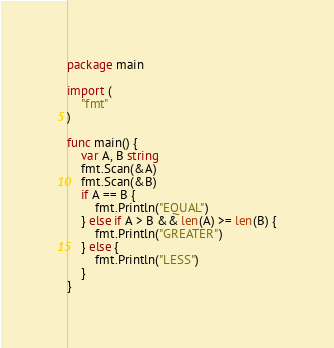<code> <loc_0><loc_0><loc_500><loc_500><_Go_>package main

import (
	"fmt"
)

func main() {
	var A, B string
	fmt.Scan(&A)
	fmt.Scan(&B)
	if A == B {
		fmt.Println("EQUAL")
	} else if A > B && len(A) >= len(B) {
		fmt.Println("GREATER")
	} else {
		fmt.Println("LESS")
	}
}
</code> 